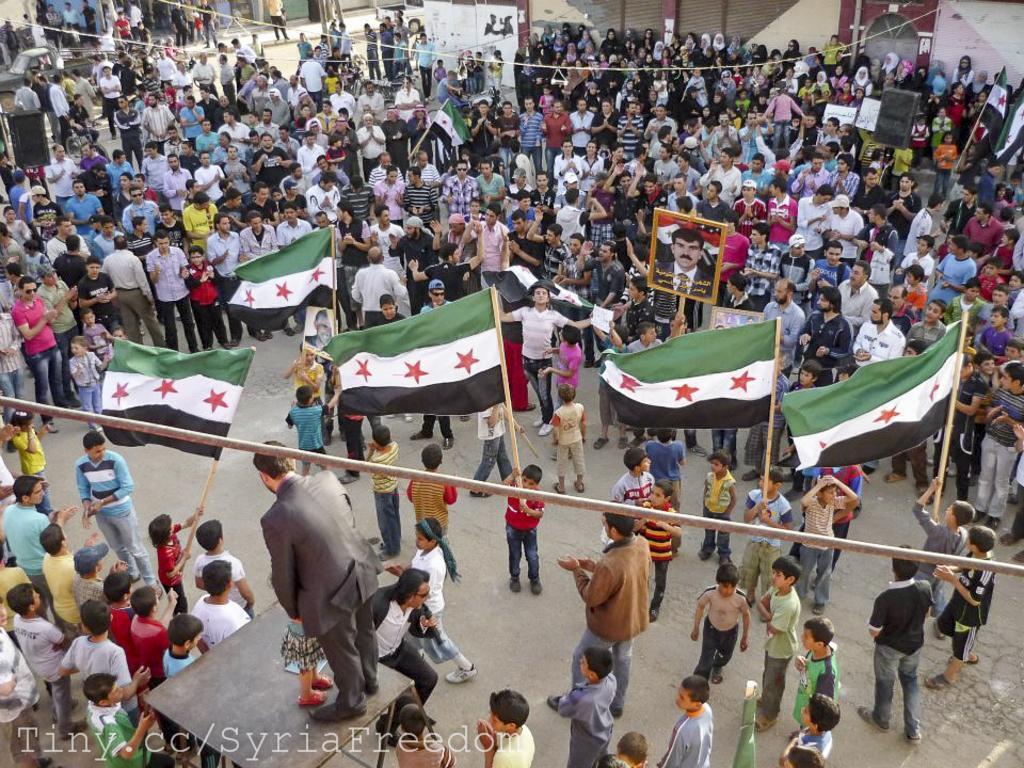Describe this image in one or two sentences. In this picture we can see a group of people standing on the road, flags, speakers, frames, table and in the background we can see vehicles, banners. 